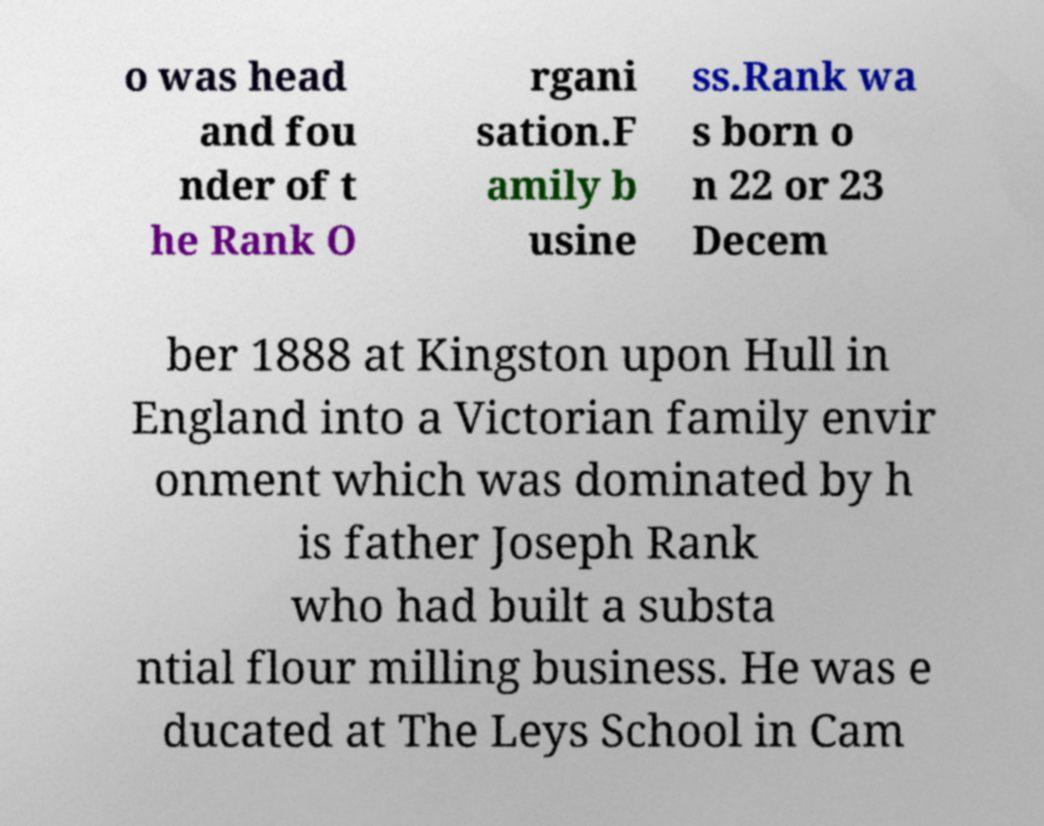I need the written content from this picture converted into text. Can you do that? o was head and fou nder of t he Rank O rgani sation.F amily b usine ss.Rank wa s born o n 22 or 23 Decem ber 1888 at Kingston upon Hull in England into a Victorian family envir onment which was dominated by h is father Joseph Rank who had built a substa ntial flour milling business. He was e ducated at The Leys School in Cam 